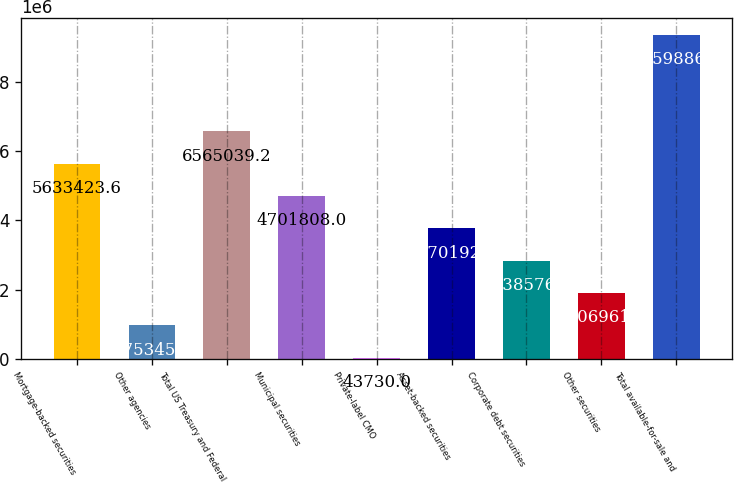Convert chart to OTSL. <chart><loc_0><loc_0><loc_500><loc_500><bar_chart><fcel>Mortgage-backed securities<fcel>Other agencies<fcel>Total US Treasury and Federal<fcel>Municipal securities<fcel>Private-label CMO<fcel>Asset-backed securities<fcel>Corporate debt securities<fcel>Other securities<fcel>Total available-for-sale and<nl><fcel>5.63342e+06<fcel>975346<fcel>6.56504e+06<fcel>4.70181e+06<fcel>43730<fcel>3.77019e+06<fcel>2.83858e+06<fcel>1.90696e+06<fcel>9.35989e+06<nl></chart> 